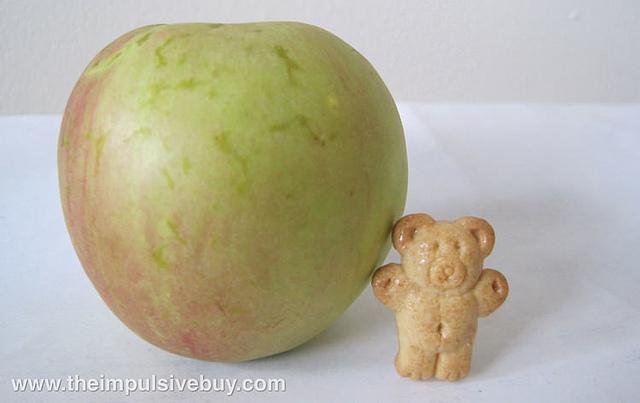How many apples are there?
Give a very brief answer. 1. How many fruits are present?
Give a very brief answer. 1. How many people are to the left of the hydrant?
Give a very brief answer. 0. 